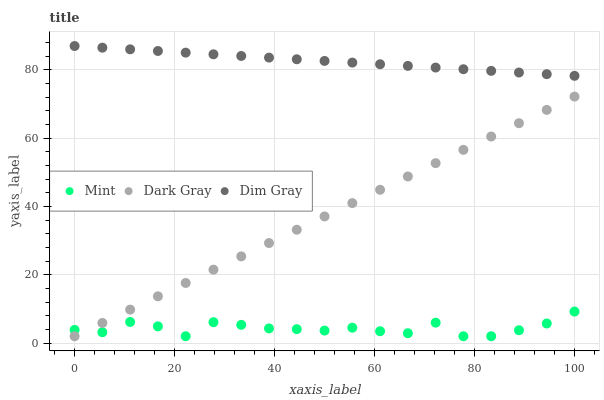Does Mint have the minimum area under the curve?
Answer yes or no. Yes. Does Dim Gray have the maximum area under the curve?
Answer yes or no. Yes. Does Dim Gray have the minimum area under the curve?
Answer yes or no. No. Does Mint have the maximum area under the curve?
Answer yes or no. No. Is Dark Gray the smoothest?
Answer yes or no. Yes. Is Mint the roughest?
Answer yes or no. Yes. Is Dim Gray the smoothest?
Answer yes or no. No. Is Dim Gray the roughest?
Answer yes or no. No. Does Dark Gray have the lowest value?
Answer yes or no. Yes. Does Dim Gray have the lowest value?
Answer yes or no. No. Does Dim Gray have the highest value?
Answer yes or no. Yes. Does Mint have the highest value?
Answer yes or no. No. Is Mint less than Dim Gray?
Answer yes or no. Yes. Is Dim Gray greater than Dark Gray?
Answer yes or no. Yes. Does Mint intersect Dark Gray?
Answer yes or no. Yes. Is Mint less than Dark Gray?
Answer yes or no. No. Is Mint greater than Dark Gray?
Answer yes or no. No. Does Mint intersect Dim Gray?
Answer yes or no. No. 